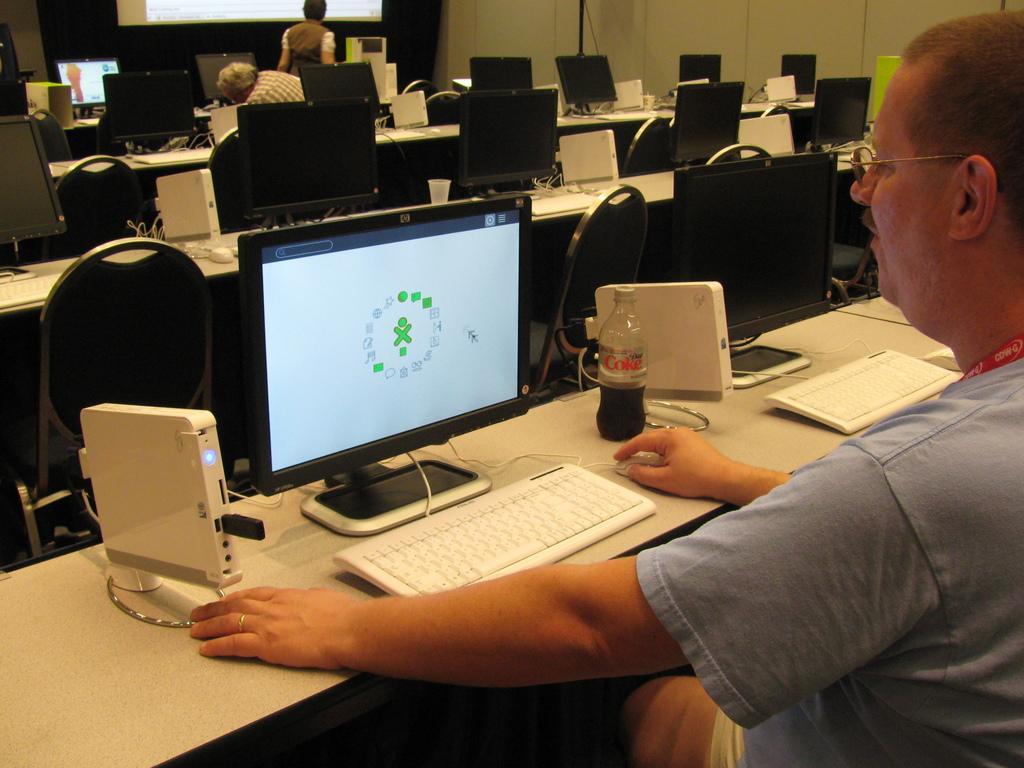In one or two sentences, can you explain what this image depicts? In this image we can see some monitors, CPUs, mouses, a pen drive, and a coke bottle on the table, we can also we see few persons, one of them is working on the computer, we can also see a glass, some chairs, and a screen. 